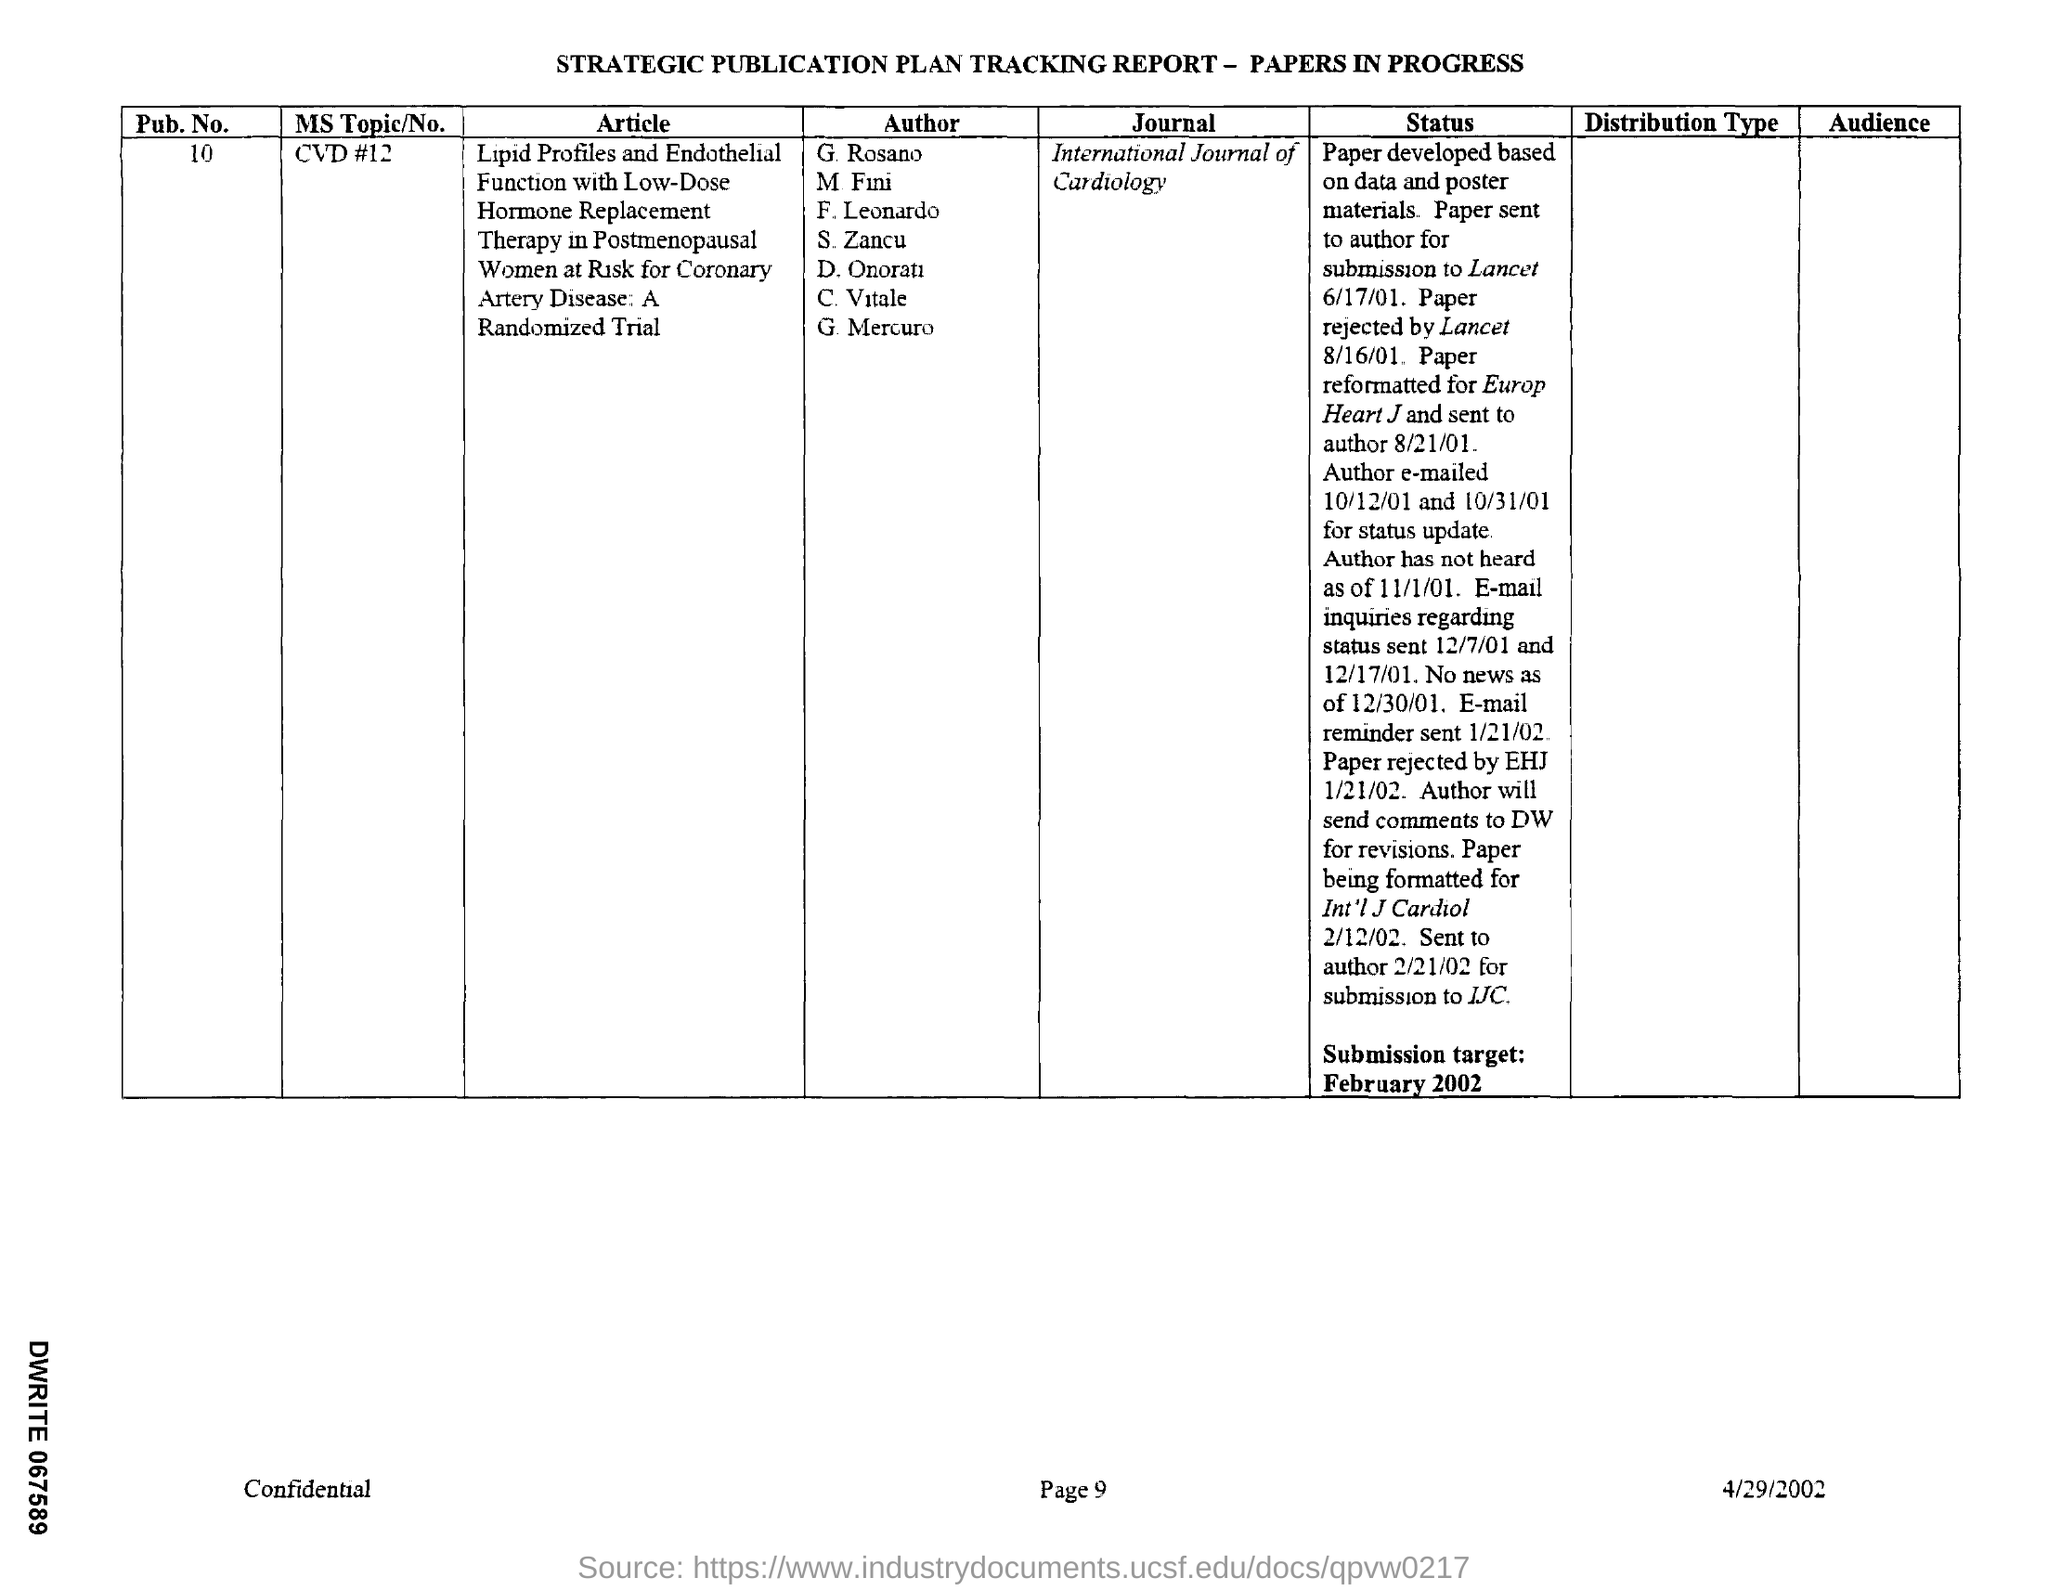Highlight a few significant elements in this photo. The tracking report contains a reference to a pub.no, which is a unique identifier for a public key. 